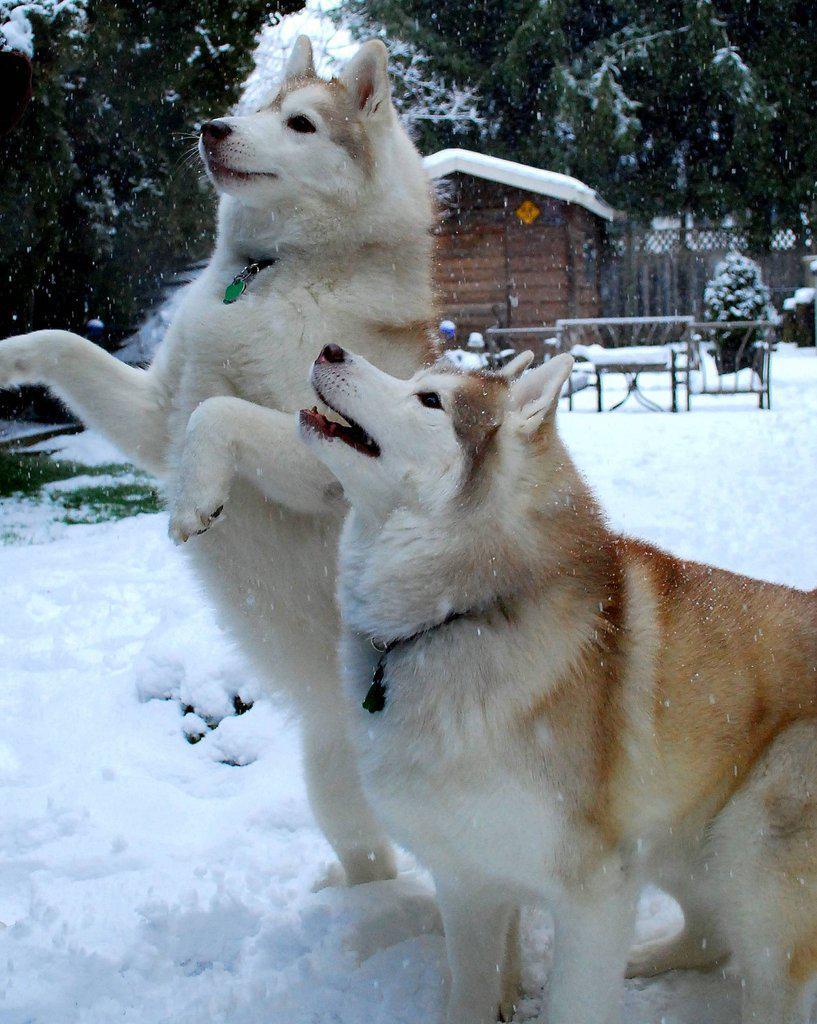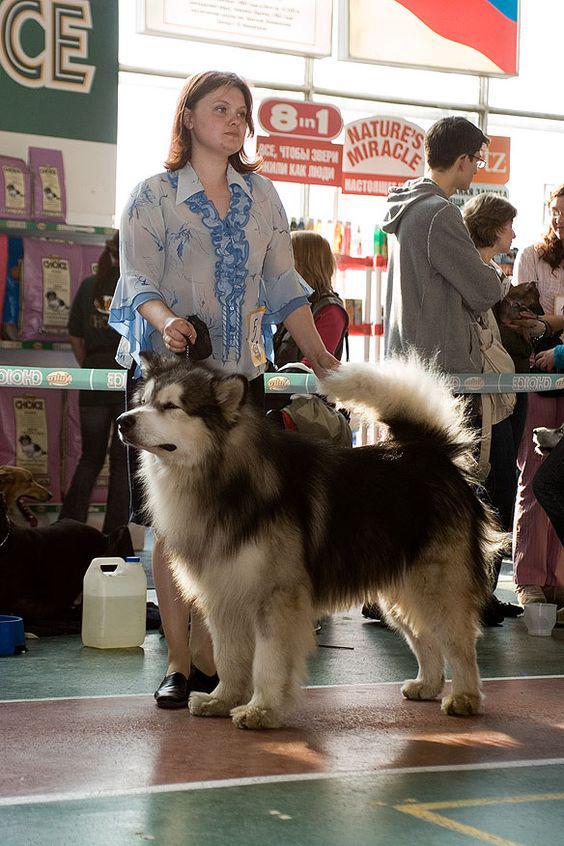The first image is the image on the left, the second image is the image on the right. For the images shown, is this caption "The dogs in the image on the left are out in the snow." true? Answer yes or no. Yes. The first image is the image on the left, the second image is the image on the right. For the images displayed, is the sentence "In one of the images, a sitting dog and a single human are visible." factually correct? Answer yes or no. No. 